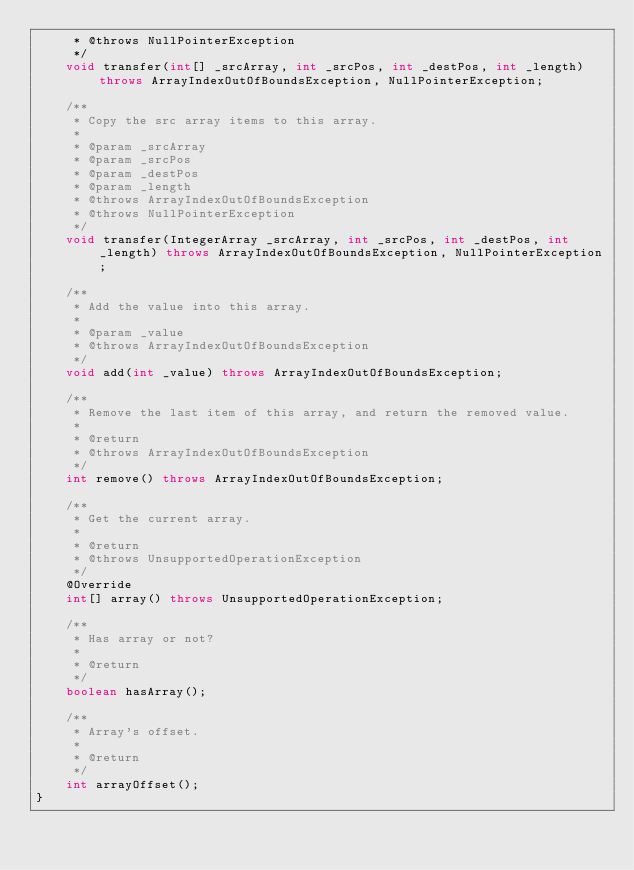Convert code to text. <code><loc_0><loc_0><loc_500><loc_500><_Java_>     * @throws NullPointerException
     */
    void transfer(int[] _srcArray, int _srcPos, int _destPos, int _length) throws ArrayIndexOutOfBoundsException, NullPointerException;

    /**
     * Copy the src array items to this array.
     *
     * @param _srcArray
     * @param _srcPos
     * @param _destPos
     * @param _length
     * @throws ArrayIndexOutOfBoundsException
     * @throws NullPointerException
     */
    void transfer(IntegerArray _srcArray, int _srcPos, int _destPos, int _length) throws ArrayIndexOutOfBoundsException, NullPointerException;

    /**
     * Add the value into this array.
     *
     * @param _value
     * @throws ArrayIndexOutOfBoundsException
     */
    void add(int _value) throws ArrayIndexOutOfBoundsException;

    /**
     * Remove the last item of this array, and return the removed value.
     *
     * @return
     * @throws ArrayIndexOutOfBoundsException
     */
    int remove() throws ArrayIndexOutOfBoundsException;

    /**
     * Get the current array.
     *
     * @return
     * @throws UnsupportedOperationException
     */
    @Override
    int[] array() throws UnsupportedOperationException;

    /**
     * Has array or not?
     *
     * @return
     */
    boolean hasArray();

    /**
     * Array's offset.
     *
     * @return
     */
    int arrayOffset();
}
</code> 